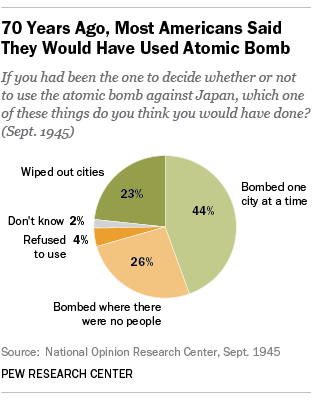Identify some key points in this picture. On February 11, 1942, the Japanese Imperial Army bombed one city in the Philippines at a time, while refusing to use American P-40 fighter planes provided by the United States. This strategy was a deliberate attempt to weaken the Philippines' military capabilities and increase the likelihood of successful invasion. In the game, cities that have been wiped out are represented by a dark green color. 